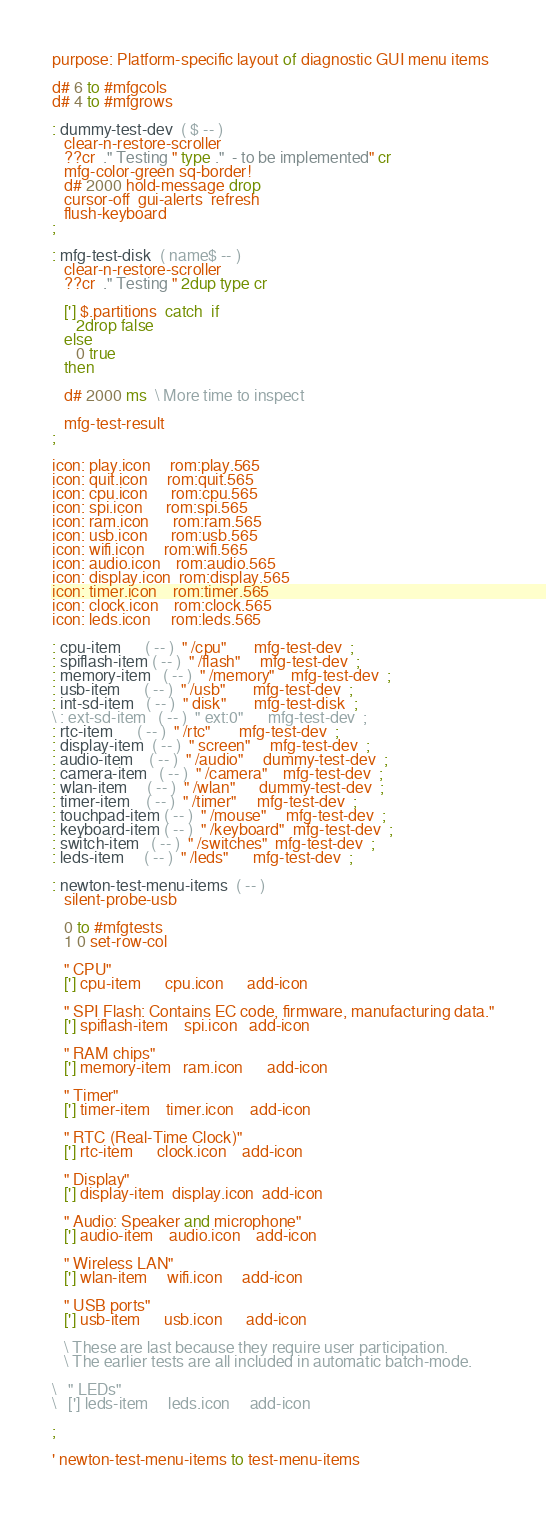<code> <loc_0><loc_0><loc_500><loc_500><_Forth_>purpose: Platform-specific layout of diagnostic GUI menu items

d# 6 to #mfgcols
d# 4 to #mfgrows

: dummy-test-dev  ( $ -- )
   clear-n-restore-scroller
   ??cr  ." Testing " type ."  - to be implemented" cr
   mfg-color-green sq-border!
   d# 2000 hold-message drop
   cursor-off  gui-alerts  refresh
   flush-keyboard
;

: mfg-test-disk  ( name$ -- )
   clear-n-restore-scroller
   ??cr  ." Testing " 2dup type cr

   ['] $.partitions  catch  if
      2drop false
   else
      0 true
   then

   d# 2000 ms  \ More time to inspect

   mfg-test-result
;

icon: play.icon     rom:play.565
icon: quit.icon     rom:quit.565
icon: cpu.icon      rom:cpu.565
icon: spi.icon      rom:spi.565
icon: ram.icon      rom:ram.565
icon: usb.icon      rom:usb.565
icon: wifi.icon     rom:wifi.565
icon: audio.icon    rom:audio.565
icon: display.icon  rom:display.565
icon: timer.icon    rom:timer.565
icon: clock.icon    rom:clock.565
icon: leds.icon     rom:leds.565

: cpu-item      ( -- )  " /cpu"       mfg-test-dev  ;
: spiflash-item ( -- )  " /flash"     mfg-test-dev  ;
: memory-item   ( -- )  " /memory"    mfg-test-dev  ;
: usb-item      ( -- )  " /usb"       mfg-test-dev  ;
: int-sd-item   ( -- )  " disk"       mfg-test-disk  ;
\ : ext-sd-item   ( -- )  " ext:0"      mfg-test-dev  ;
: rtc-item      ( -- )  " /rtc"       mfg-test-dev  ;
: display-item  ( -- )  " screen"     mfg-test-dev  ;
: audio-item    ( -- )  " /audio"     dummy-test-dev  ;
: camera-item   ( -- )  " /camera"    mfg-test-dev  ;
: wlan-item     ( -- )  " /wlan"      dummy-test-dev  ;
: timer-item    ( -- )  " /timer"     mfg-test-dev  ;
: touchpad-item ( -- )  " /mouse"     mfg-test-dev  ;
: keyboard-item ( -- )  " /keyboard"  mfg-test-dev  ;
: switch-item   ( -- )  " /switches"  mfg-test-dev  ;
: leds-item     ( -- )  " /leds"      mfg-test-dev  ;

: newton-test-menu-items  ( -- )
   silent-probe-usb

   0 to #mfgtests
   1 0 set-row-col

   " CPU"
   ['] cpu-item      cpu.icon      add-icon

   " SPI Flash: Contains EC code, firmware, manufacturing data."
   ['] spiflash-item    spi.icon   add-icon

   " RAM chips"
   ['] memory-item   ram.icon      add-icon

   " Timer"
   ['] timer-item    timer.icon    add-icon

   " RTC (Real-Time Clock)"
   ['] rtc-item      clock.icon    add-icon

   " Display"
   ['] display-item  display.icon  add-icon

   " Audio: Speaker and microphone"
   ['] audio-item    audio.icon    add-icon

   " Wireless LAN"
   ['] wlan-item     wifi.icon     add-icon

   " USB ports"
   ['] usb-item      usb.icon      add-icon

   \ These are last because they require user participation.
   \ The earlier tests are all included in automatic batch-mode.

\   " LEDs"
\   ['] leds-item     leds.icon     add-icon

;

' newton-test-menu-items to test-menu-items
</code> 